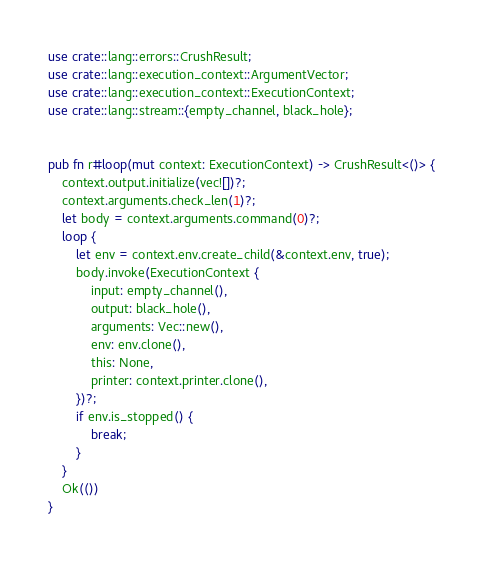Convert code to text. <code><loc_0><loc_0><loc_500><loc_500><_Rust_>use crate::lang::errors::CrushResult;
use crate::lang::execution_context::ArgumentVector;
use crate::lang::execution_context::ExecutionContext;
use crate::lang::stream::{empty_channel, black_hole};


pub fn r#loop(mut context: ExecutionContext) -> CrushResult<()> {
    context.output.initialize(vec![])?;
    context.arguments.check_len(1)?;
    let body = context.arguments.command(0)?;
    loop {
        let env = context.env.create_child(&context.env, true);
        body.invoke(ExecutionContext {
            input: empty_channel(),
            output: black_hole(),
            arguments: Vec::new(),
            env: env.clone(),
            this: None,
            printer: context.printer.clone(),
        })?;
        if env.is_stopped() {
            break;
        }
    }
    Ok(())
}
</code> 